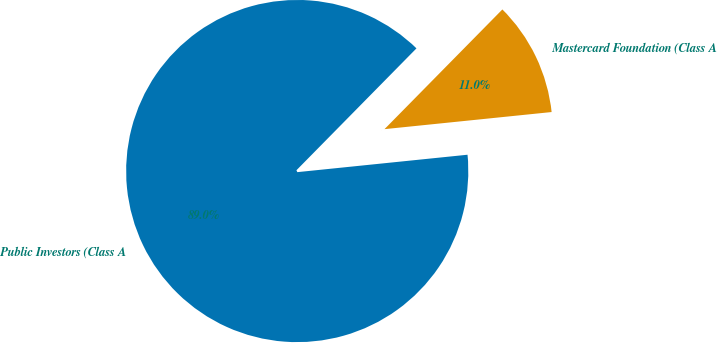Convert chart to OTSL. <chart><loc_0><loc_0><loc_500><loc_500><pie_chart><fcel>Public Investors (Class A<fcel>Mastercard Foundation (Class A<nl><fcel>89.0%<fcel>11.0%<nl></chart> 